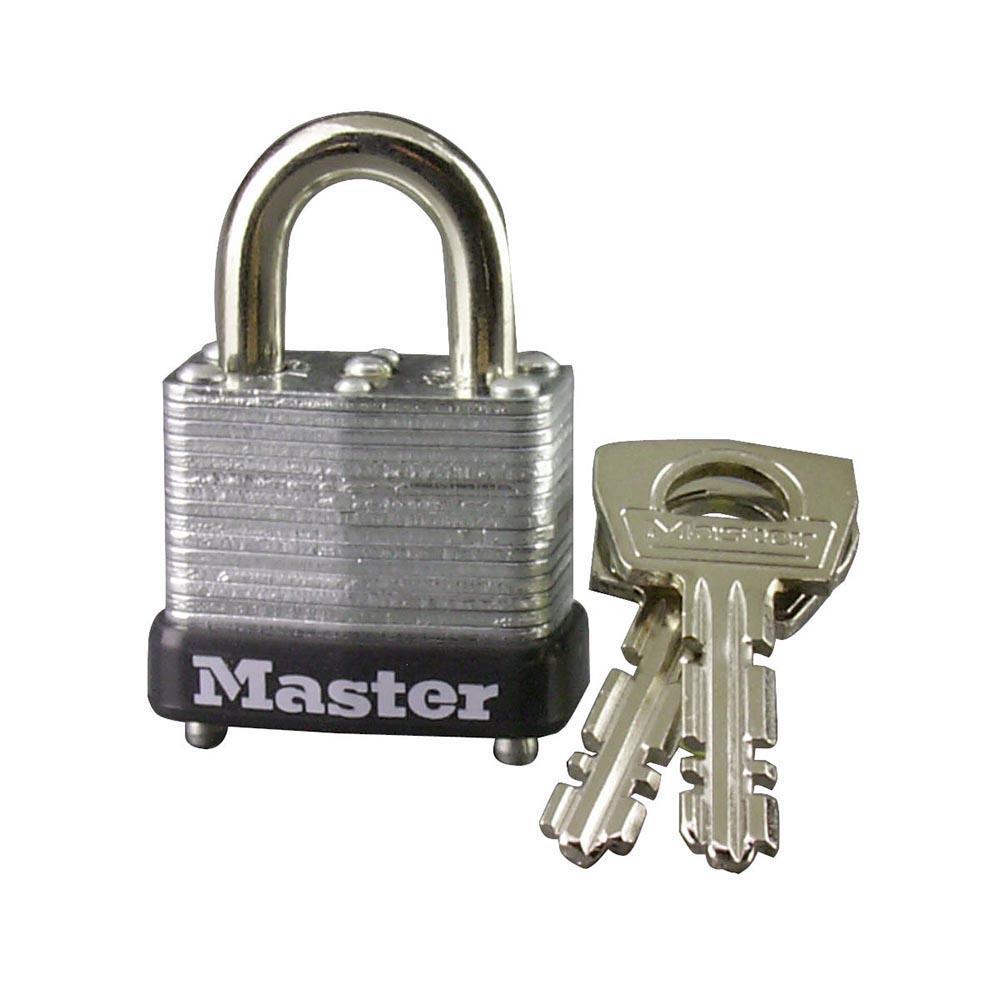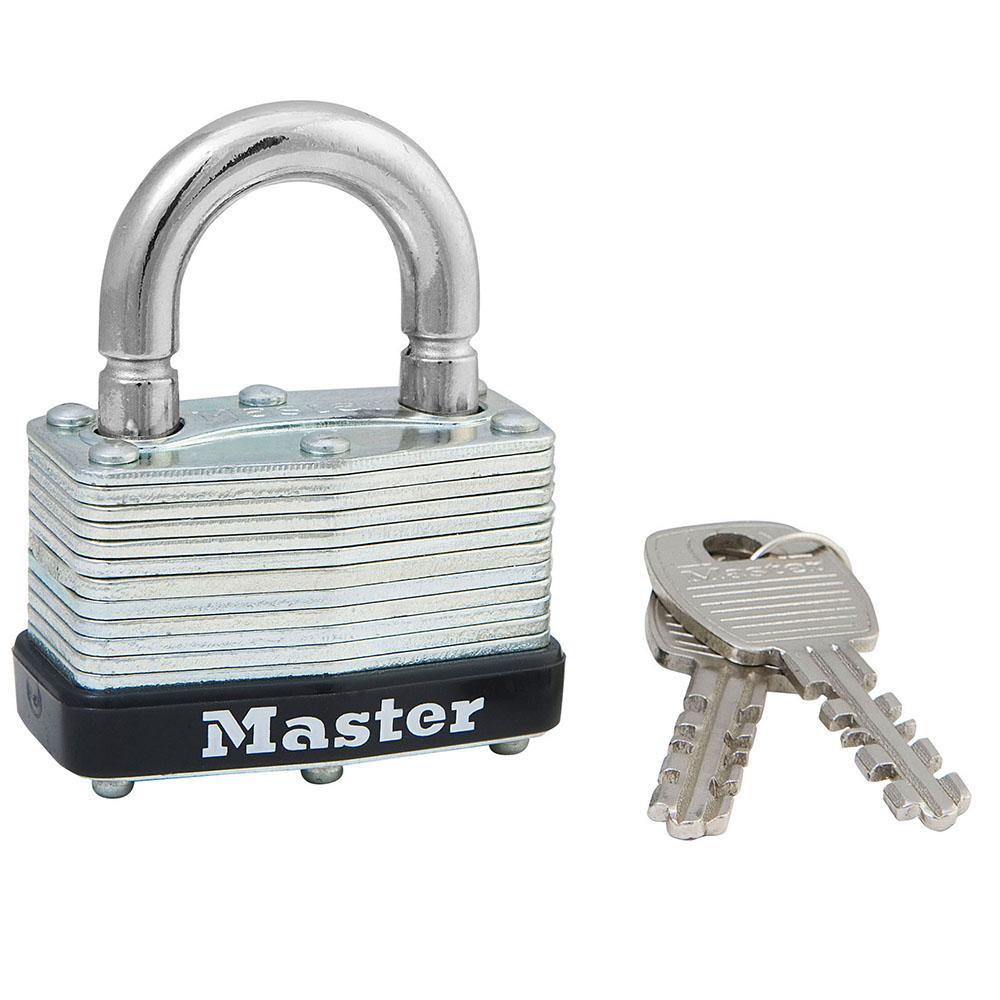The first image is the image on the left, the second image is the image on the right. For the images shown, is this caption "Each image contains only one lock, and each lock has a silver loop at the top." true? Answer yes or no. Yes. The first image is the image on the left, the second image is the image on the right. Analyze the images presented: Is the assertion "Two locks each have two keys and the same logo designs, but have differences in the lock mechanisms above the bases." valid? Answer yes or no. Yes. 